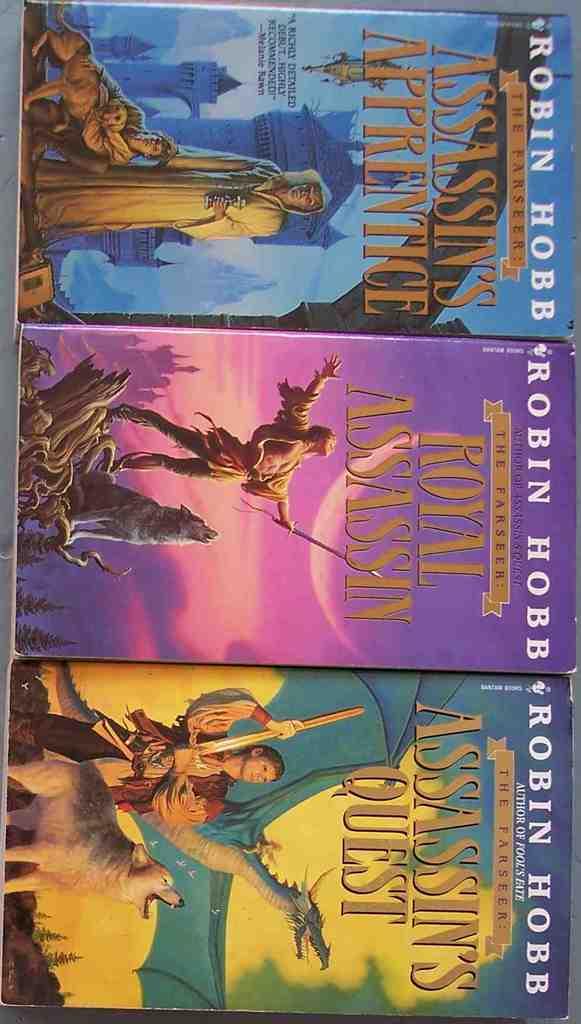What are the names of these books?
Give a very brief answer. Assassins apprentice, royal assassin, assassins quest. Who is the author of the books?
Keep it short and to the point. Robin hobb. 